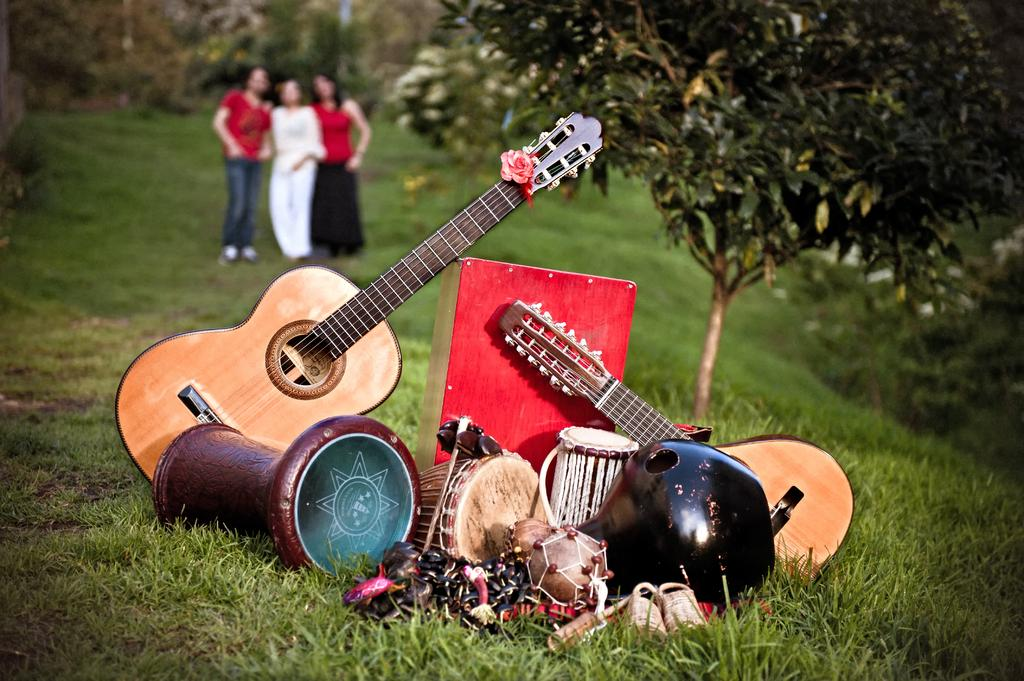What objects are present in the image that are related to music? There are musical instruments in the image. How many people are standing on the grass in the image? There are three persons standing on the grass in the image. What type of natural environment is visible in the image? There are trees in the image, indicating a natural setting. What is the sister of the person holding the guitar doing in the image? There is no mention of a sister or any other person besides the three standing on the grass in the image. 